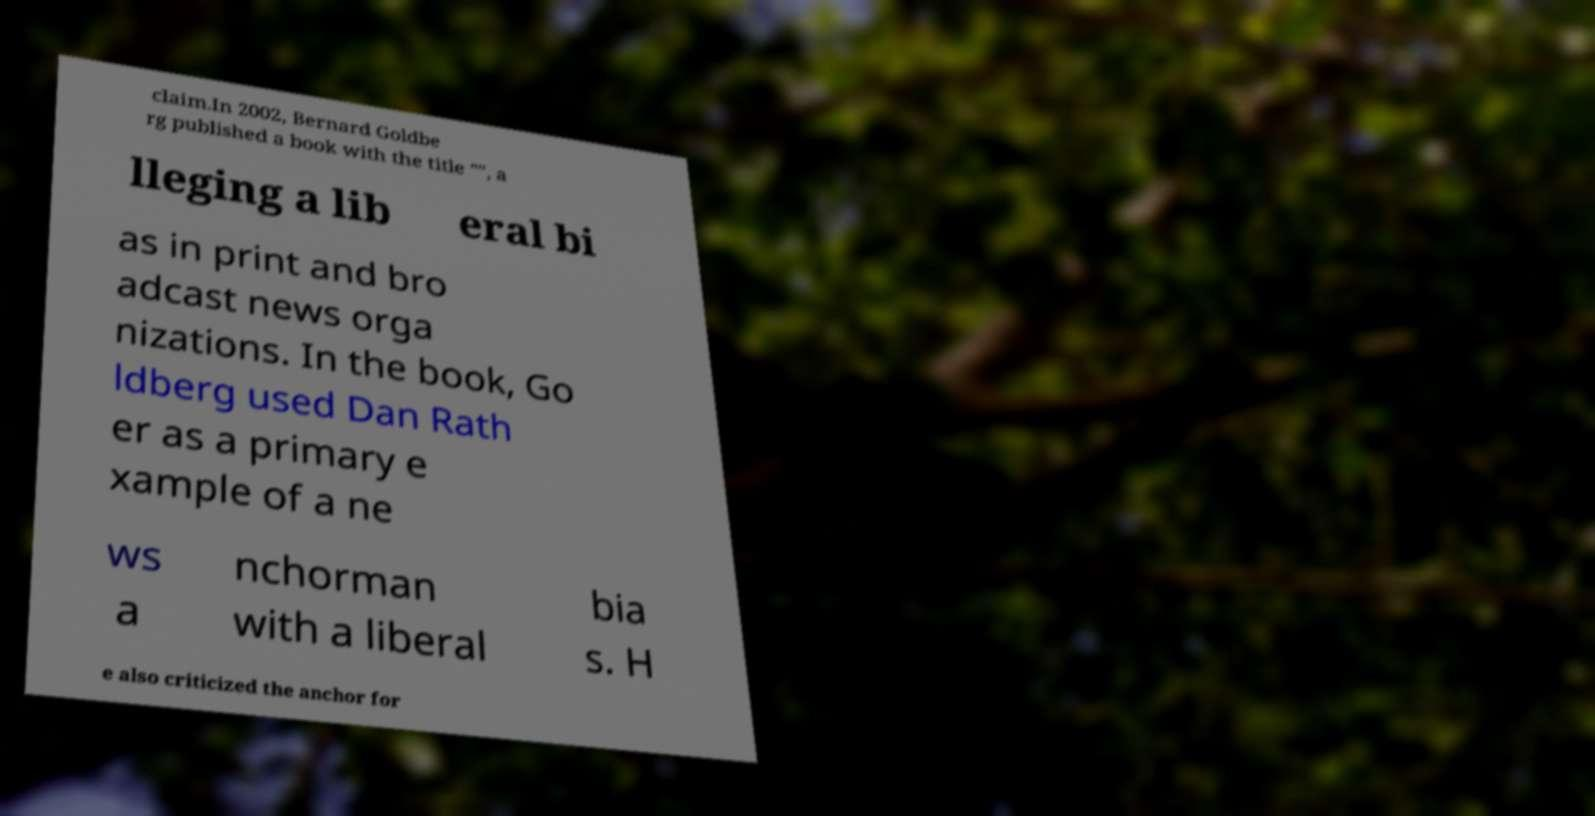Could you extract and type out the text from this image? claim.In 2002, Bernard Goldbe rg published a book with the title "", a lleging a lib eral bi as in print and bro adcast news orga nizations. In the book, Go ldberg used Dan Rath er as a primary e xample of a ne ws a nchorman with a liberal bia s. H e also criticized the anchor for 